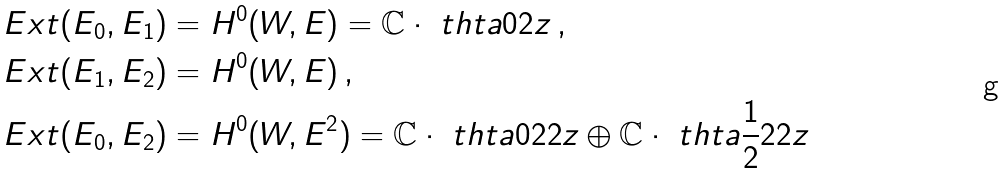Convert formula to latex. <formula><loc_0><loc_0><loc_500><loc_500>E x t ( E _ { 0 } , E _ { 1 } ) & = H ^ { 0 } ( W , E ) = \mathbb { C } \cdot \ t h t a { 0 } { 2 } { z } \, , \\ E x t ( E _ { 1 } , E _ { 2 } ) & = H ^ { 0 } ( W , E ) \, , \\ E x t ( E _ { 0 } , E _ { 2 } ) & = H ^ { 0 } ( W , E ^ { 2 } ) = \mathbb { C } \cdot \ t h t a { 0 } { 2 } { 2 z } \oplus \mathbb { C } \cdot \ t h t a { \frac { 1 } { 2 } } { 2 } { 2 z }</formula> 